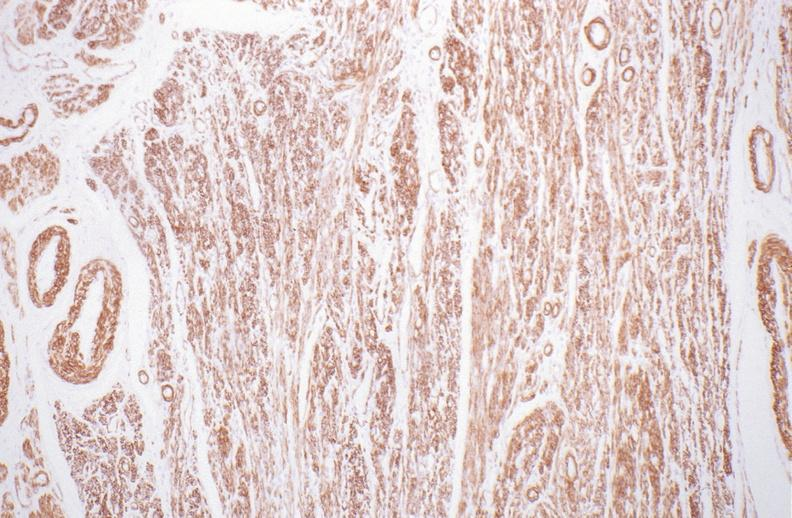s female reproductive present?
Answer the question using a single word or phrase. Yes 